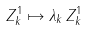<formula> <loc_0><loc_0><loc_500><loc_500>Z _ { k } ^ { 1 } \mapsto \lambda _ { k } \, Z _ { k } ^ { 1 }</formula> 